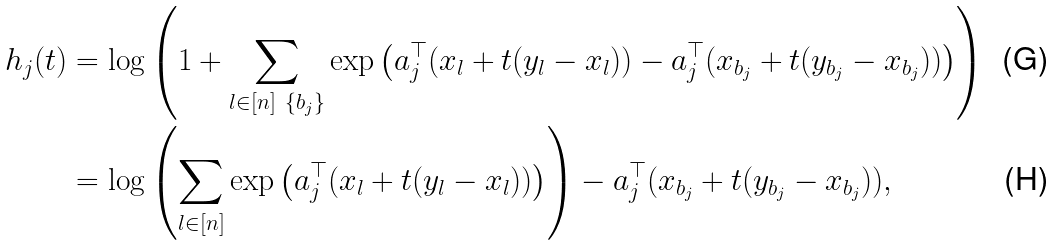Convert formula to latex. <formula><loc_0><loc_0><loc_500><loc_500>h _ { j } ( t ) & = \log \left ( 1 + \sum _ { l \in [ n ] \ \{ b _ { j } \} } \exp \left ( a _ { j } ^ { \top } ( x _ { l } + t ( y _ { l } - x _ { l } ) ) - a _ { j } ^ { \top } ( x _ { b _ { j } } + t ( y _ { b _ { j } } - x _ { b _ { j } } ) ) \right ) \right ) \\ & = \log \left ( \sum _ { l \in [ n ] } \exp \left ( a _ { j } ^ { \top } ( x _ { l } + t ( y _ { l } - x _ { l } ) ) \right ) \right ) - a _ { j } ^ { \top } ( x _ { b _ { j } } + t ( y _ { b _ { j } } - x _ { b _ { j } } ) ) ,</formula> 